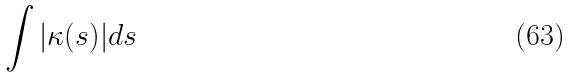<formula> <loc_0><loc_0><loc_500><loc_500>\int | \kappa ( s ) | d s</formula> 